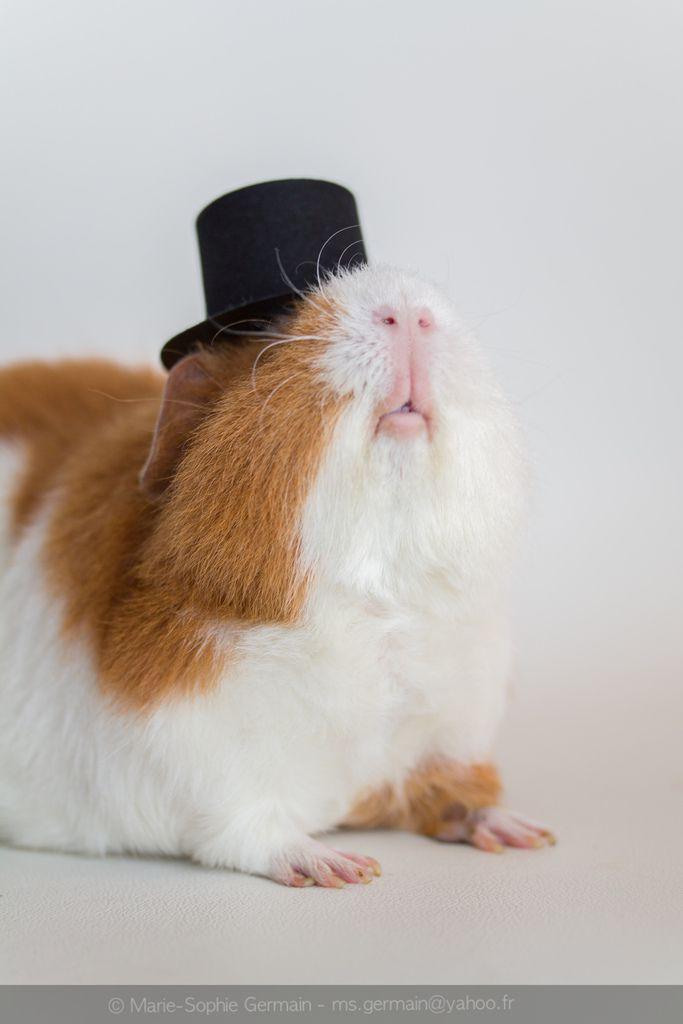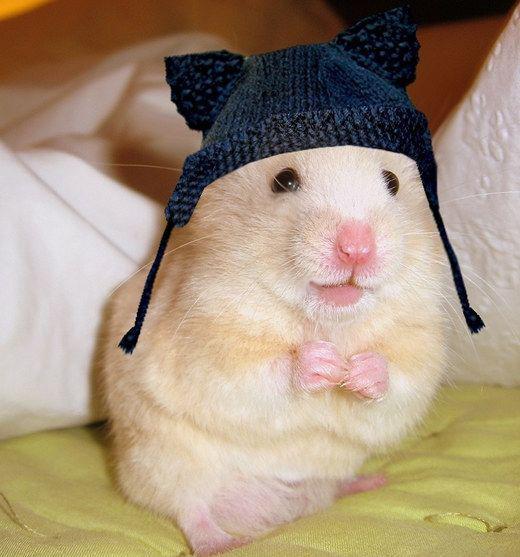The first image is the image on the left, the second image is the image on the right. Considering the images on both sides, is "Exactly one guinea pig is wearing a top hat." valid? Answer yes or no. Yes. The first image is the image on the left, the second image is the image on the right. For the images displayed, is the sentence "The rodent in the image on the left is standing while wearing a top hat." factually correct? Answer yes or no. No. 